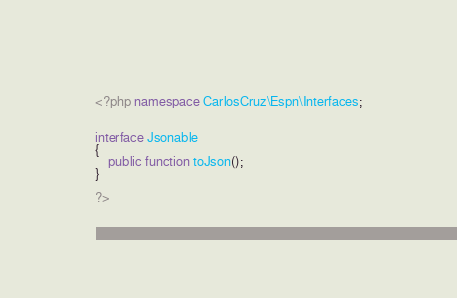<code> <loc_0><loc_0><loc_500><loc_500><_PHP_><?php namespace CarlosCruz\Espn\Interfaces;


interface Jsonable
{
    public function toJson();
}

?>
</code> 